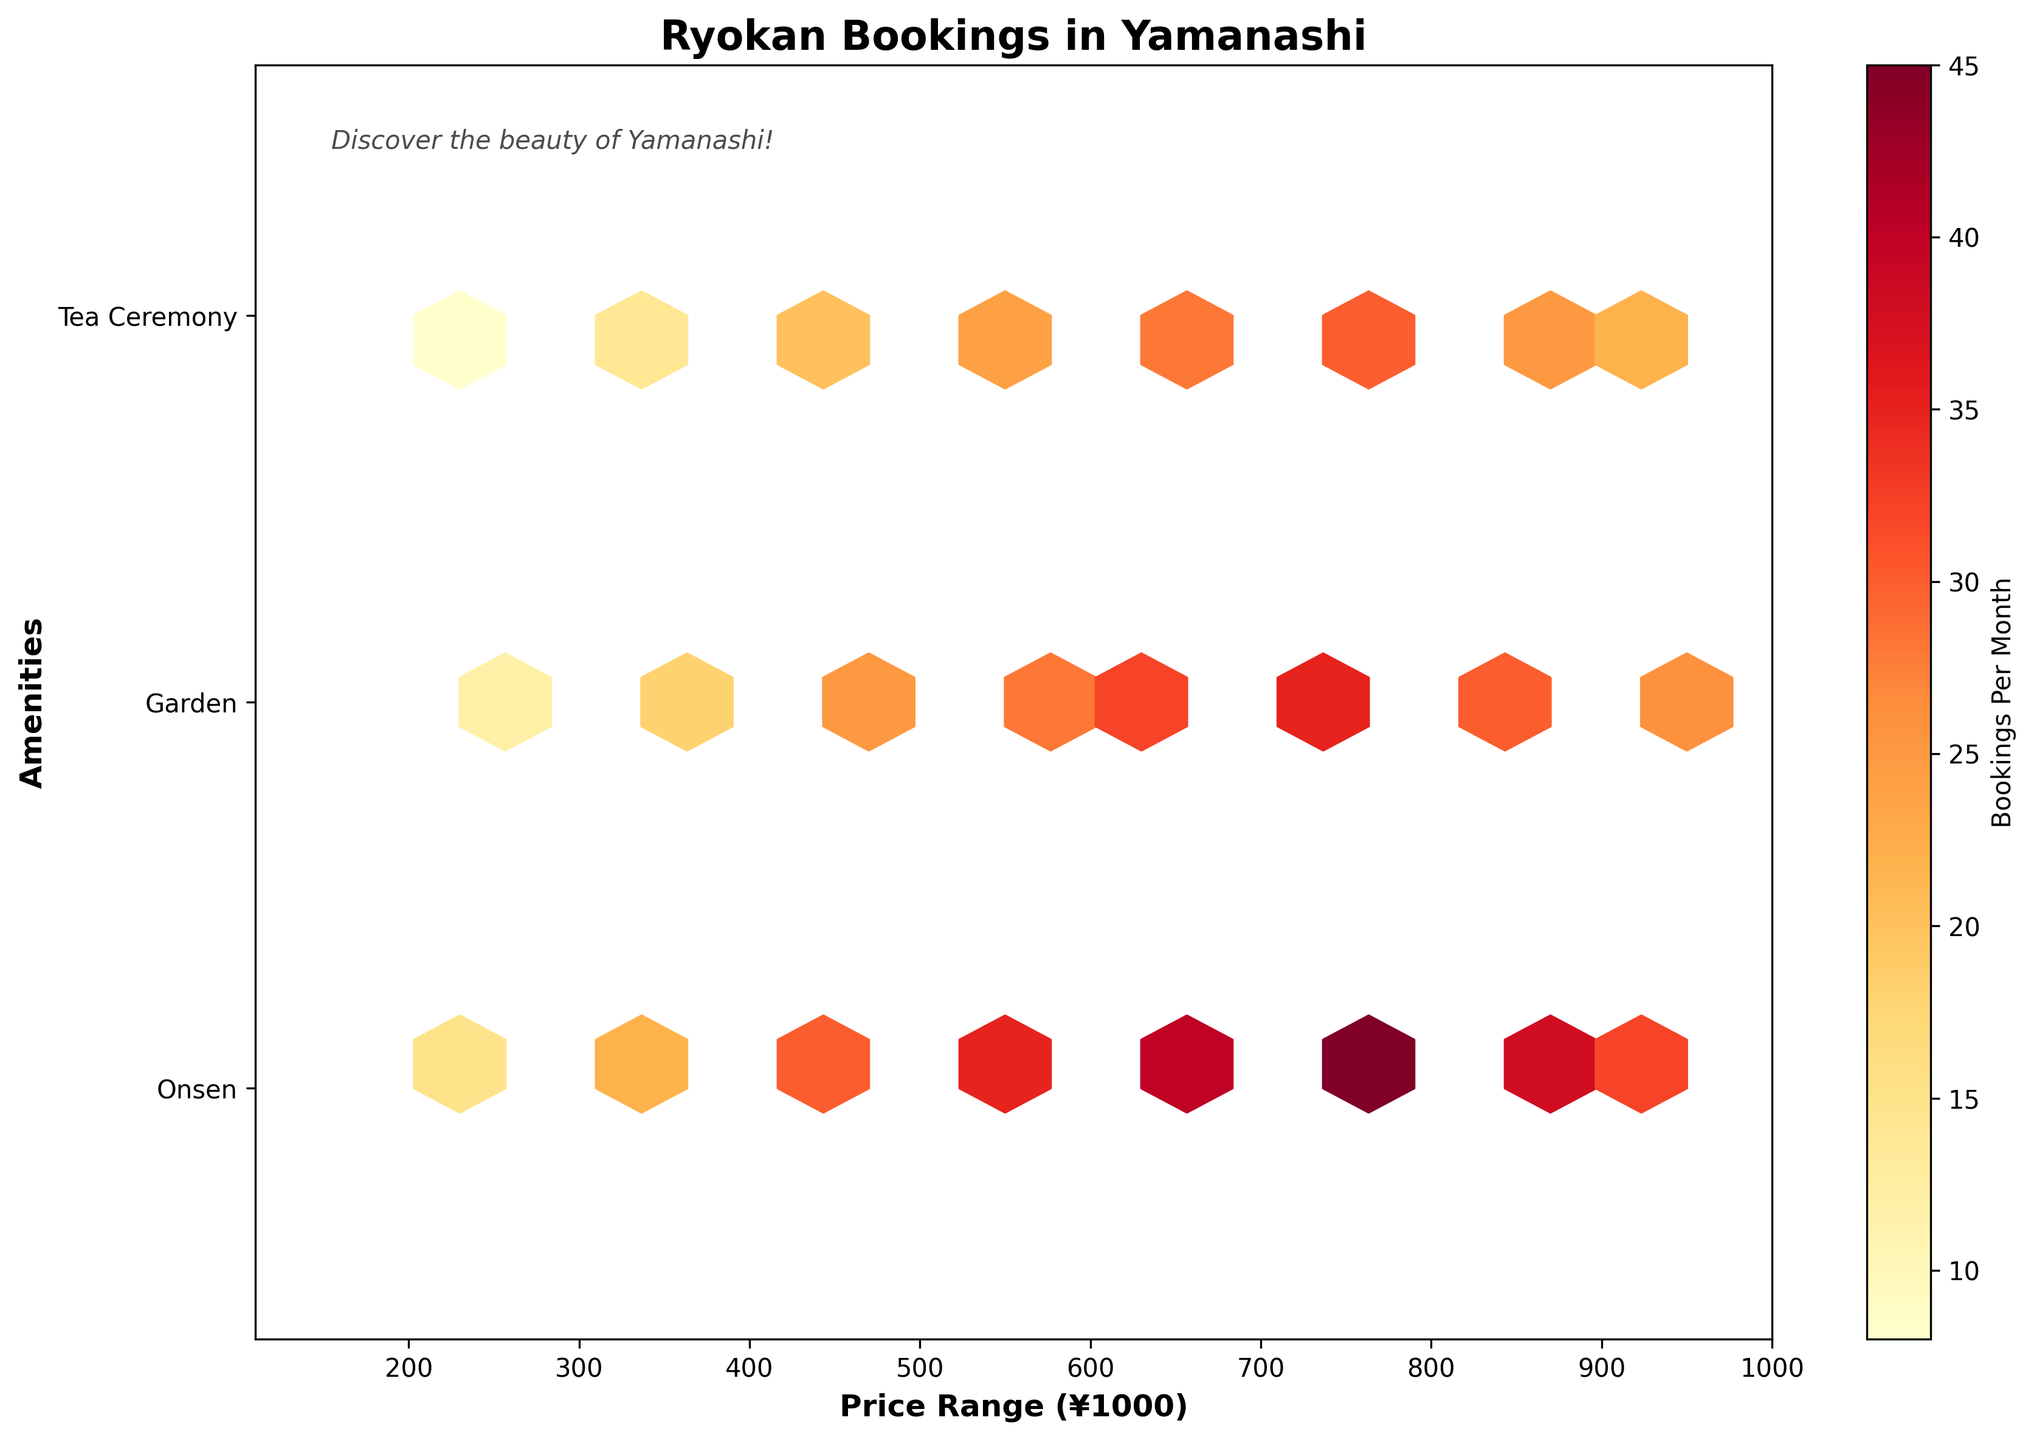what is the title of the plot? The title of the plot is located at the top center of the figure. It helps to quickly understand the overall theme of the plot.
Answer: Ryokan Bookings in Yamanashi What are the axes' labels? The axes' labels indicate what each axis represents. The x-axis is labeled with 'Price Range (¥1000)' and the y-axis with 'Amenities'.
Answer: x: Price Range (¥1000), y: Amenities what color represents the highest number of bookings per month? The color closer to red in the color bar indicates a higher number of bookings per month.
Answer: Red What is the highest price range shown on the x-axis? The highest price range shown on the x-axis can be identified by looking at the farthest tick mark to the right. It is ¥1000.
Answer: 1000 how many types of amenities are plotted on the y-axis? By examining the y-axis, you can count the variety of unique amenities. The plot shows Onsen, Garden, and Tea Ceremony.
Answer: 3 types Which amenity generally has the highest booking rates? Generally, you can check which amenity's data points are closer to the reddish color, indicating higher bookings. From the plot, Onsen (encoded as 1) is frequently seen in redder shades.
Answer: Onsen Compare the booking rates for a price range of 700-800 for Onsen and Tea Ceremony. Which one is higher? Look at the data points corresponding to the price range of 700-800 and compare the hexbin colors of Onsen (1) and Tea Ceremony (3). Onsen is in a darker color (more towards red) than Tea Ceremony.
Answer: Onsen which price range has the most varied booking rates? Price range with the most varied booking rates can be identified by seeing which price range has the most different colors, indicating high variation. The range 700-800 shows a wide variation from dark orange to bright red.
Answer: 700-800 For price ranges between 400-500, which amenity has the fewest bookings? Scan the 400-500 price range for the data point with the lightest color (less bookings) among the different amenities. Tea Ceremony has the lightest color.
Answer: Tea Ceremony 